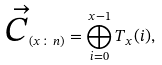Convert formula to latex. <formula><loc_0><loc_0><loc_500><loc_500>\overrightarrow { C } _ { ( x \colon n ) } = \bigoplus _ { i = 0 } ^ { x - 1 } T _ { x } ( i ) ,</formula> 